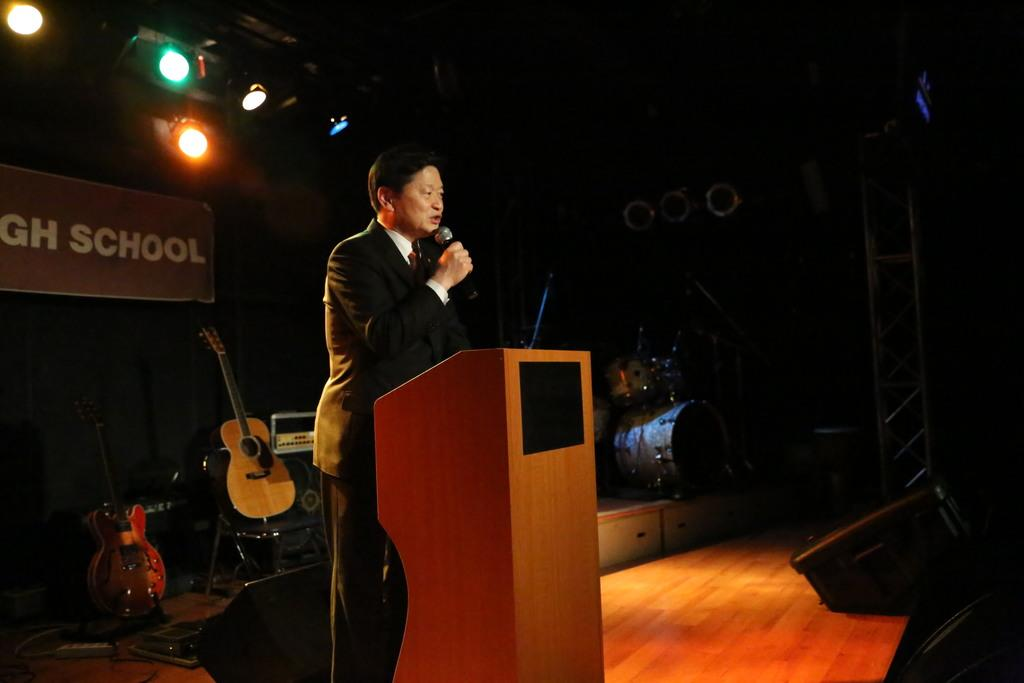What is the man in the image doing near the podium? The man is standing near a podium in the image. What other objects related to music can be seen in the image? There are musical instruments in the image. What type of furniture is present in the image? There is a chair in the image. What kind of signage is visible in the image? There is a poster in the image. What source of illumination is present in the image? There is a light in the image. What type of toys can be seen on the podium in the image? There are no toys present on the podium or in the image. What belief system is being promoted by the poster in the image? The poster in the image does not promote any specific belief system; it is simply a sign with text and graphics. 